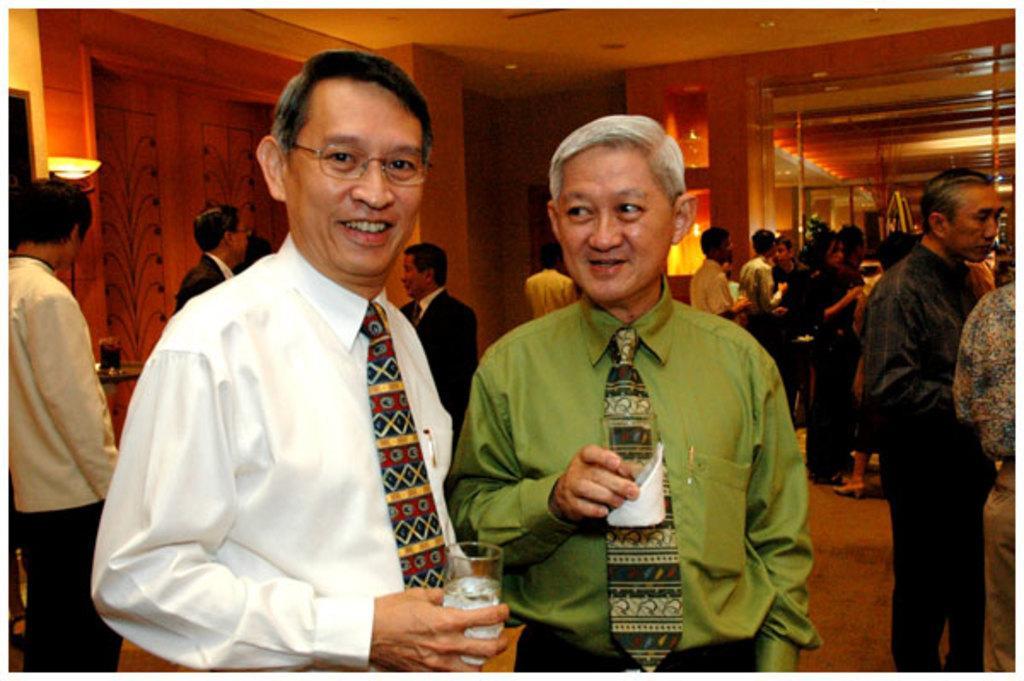Please provide a concise description of this image. In this picture we can see a man holding an object. There is a person holding an object in his hand. We can see a box on the shelf. There are some lights 